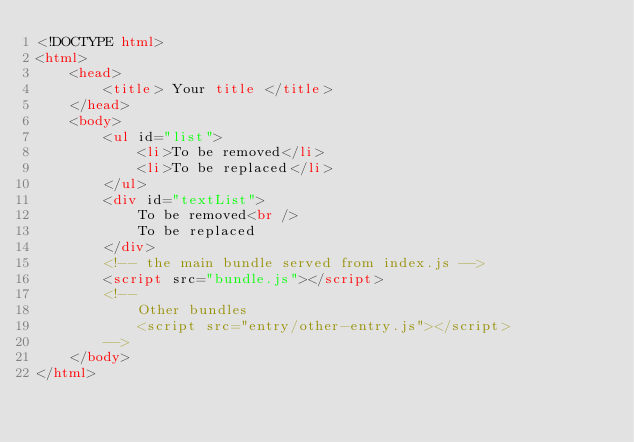Convert code to text. <code><loc_0><loc_0><loc_500><loc_500><_HTML_><!DOCTYPE html>
<html>
    <head>
        <title> Your title </title>
    </head>
    <body>
        <ul id="list">
            <li>To be removed</li>
            <li>To be replaced</li>
        </ul>
        <div id="textList">
            To be removed<br />
            To be replaced
        </div>
        <!-- the main bundle served from index.js -->
        <script src="bundle.js"></script>
        <!--
            Other bundles
            <script src="entry/other-entry.js"></script>
        -->
    </body>
</html></code> 